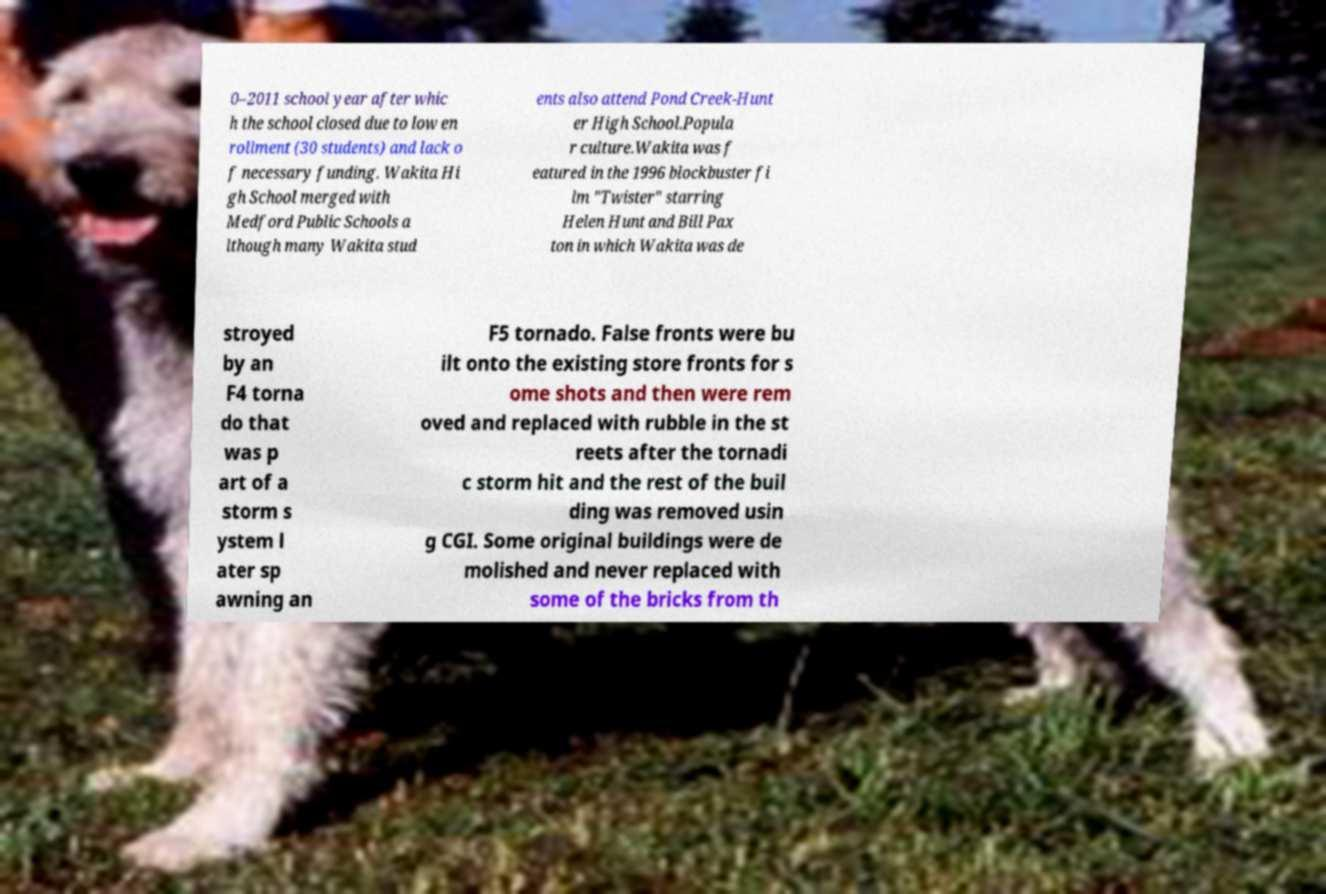Could you assist in decoding the text presented in this image and type it out clearly? 0–2011 school year after whic h the school closed due to low en rollment (30 students) and lack o f necessary funding. Wakita Hi gh School merged with Medford Public Schools a lthough many Wakita stud ents also attend Pond Creek-Hunt er High School.Popula r culture.Wakita was f eatured in the 1996 blockbuster fi lm "Twister" starring Helen Hunt and Bill Pax ton in which Wakita was de stroyed by an F4 torna do that was p art of a storm s ystem l ater sp awning an F5 tornado. False fronts were bu ilt onto the existing store fronts for s ome shots and then were rem oved and replaced with rubble in the st reets after the tornadi c storm hit and the rest of the buil ding was removed usin g CGI. Some original buildings were de molished and never replaced with some of the bricks from th 